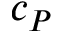Convert formula to latex. <formula><loc_0><loc_0><loc_500><loc_500>c _ { P }</formula> 